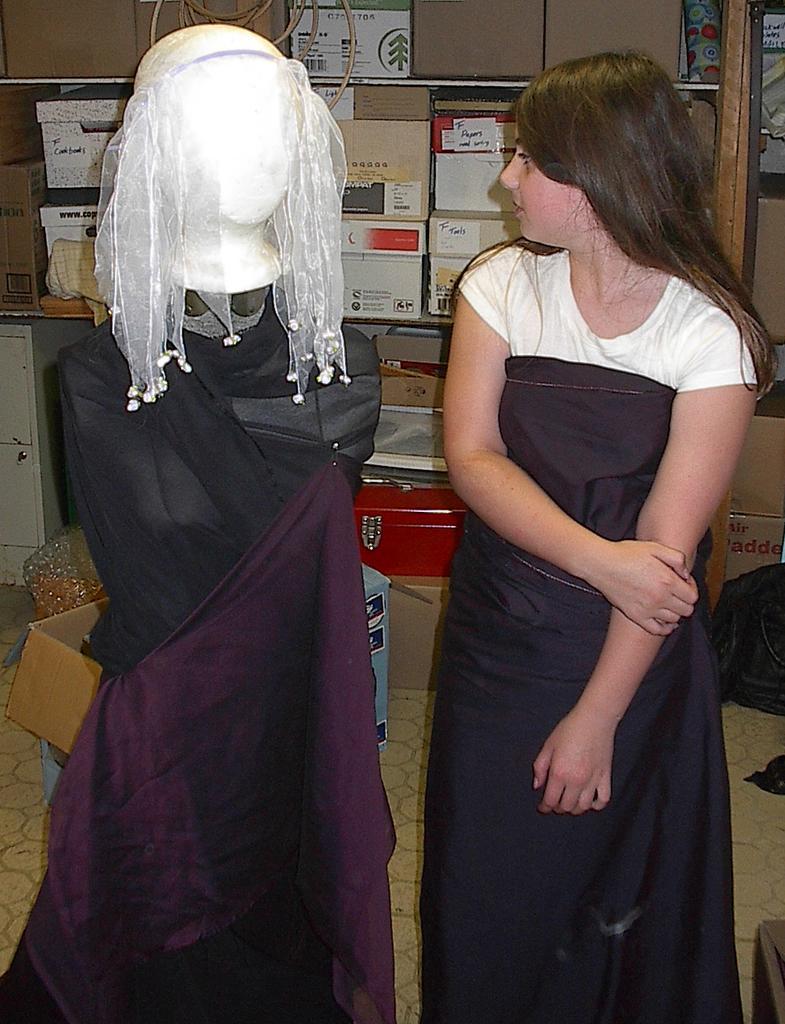Could you give a brief overview of what you see in this image? In this image we can see a lady standing, next to her there is a mannequin and there are clothes placed on it. In the background there are cardboard boxes and a wall. 